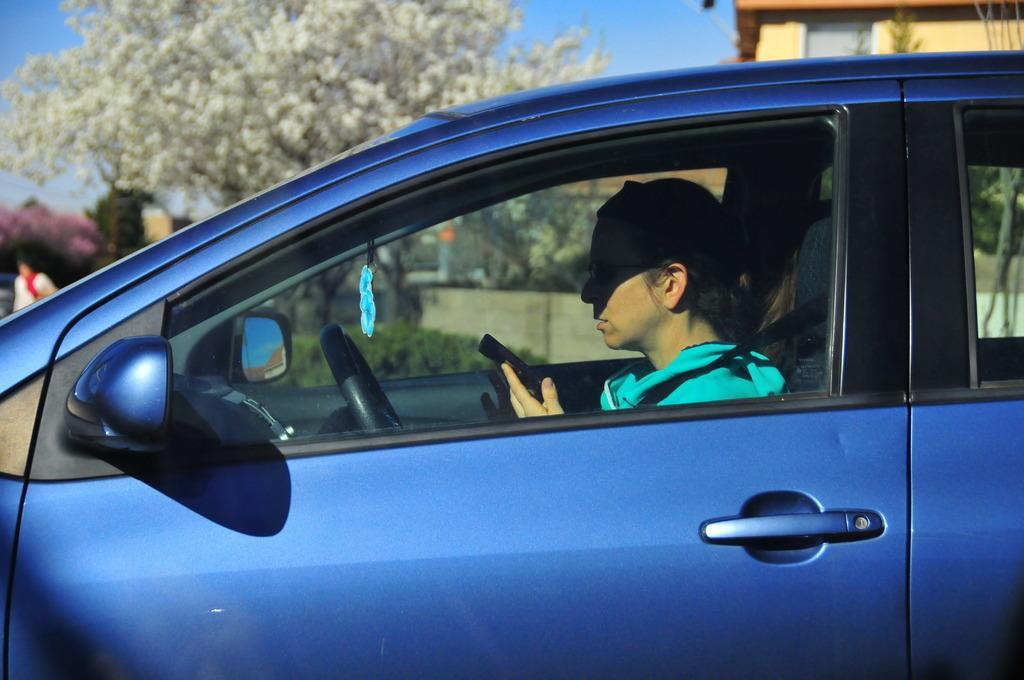How would you summarize this image in a sentence or two? In this image there is a blue color car. There is a man sitting inside the car is holding a mobile. In the background there is a tree, building and the sky. 